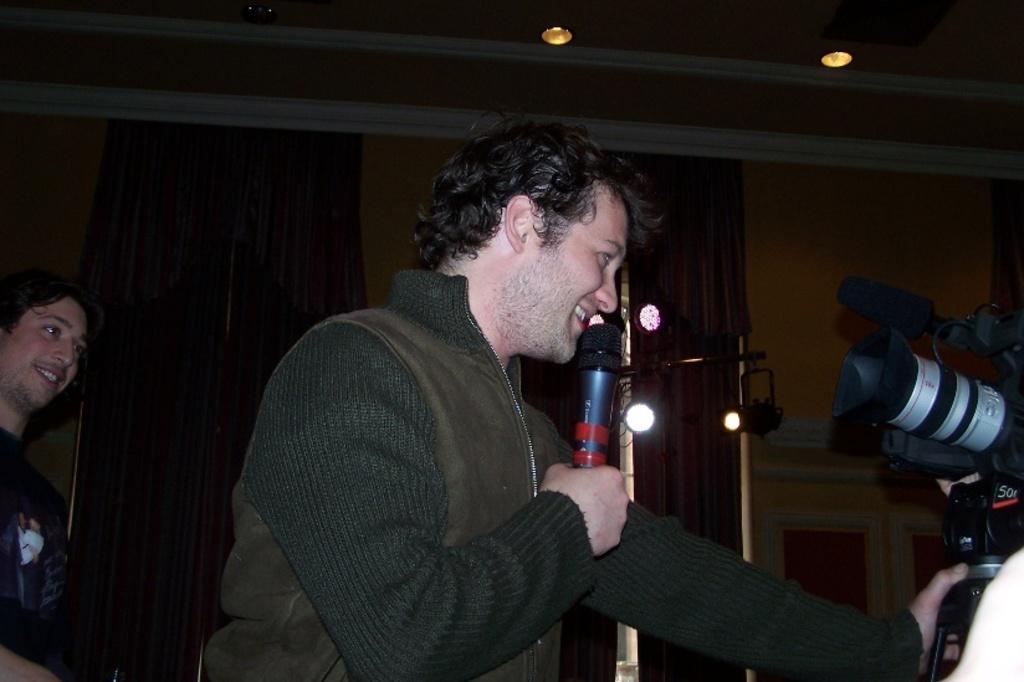Can you describe this image briefly? This picture shows a man standing and holding a mic in his hand. He is smiling. In the background there is another person standing and smiling. There is a camera in the right side. In the background there is a curtain and a wall here. 